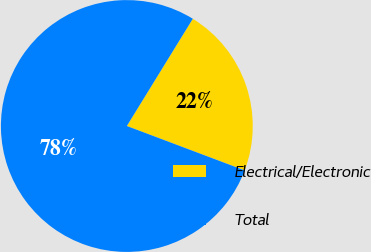Convert chart to OTSL. <chart><loc_0><loc_0><loc_500><loc_500><pie_chart><fcel>Electrical/Electronic<fcel>Total<nl><fcel>21.96%<fcel>78.04%<nl></chart> 